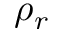Convert formula to latex. <formula><loc_0><loc_0><loc_500><loc_500>\rho _ { r }</formula> 